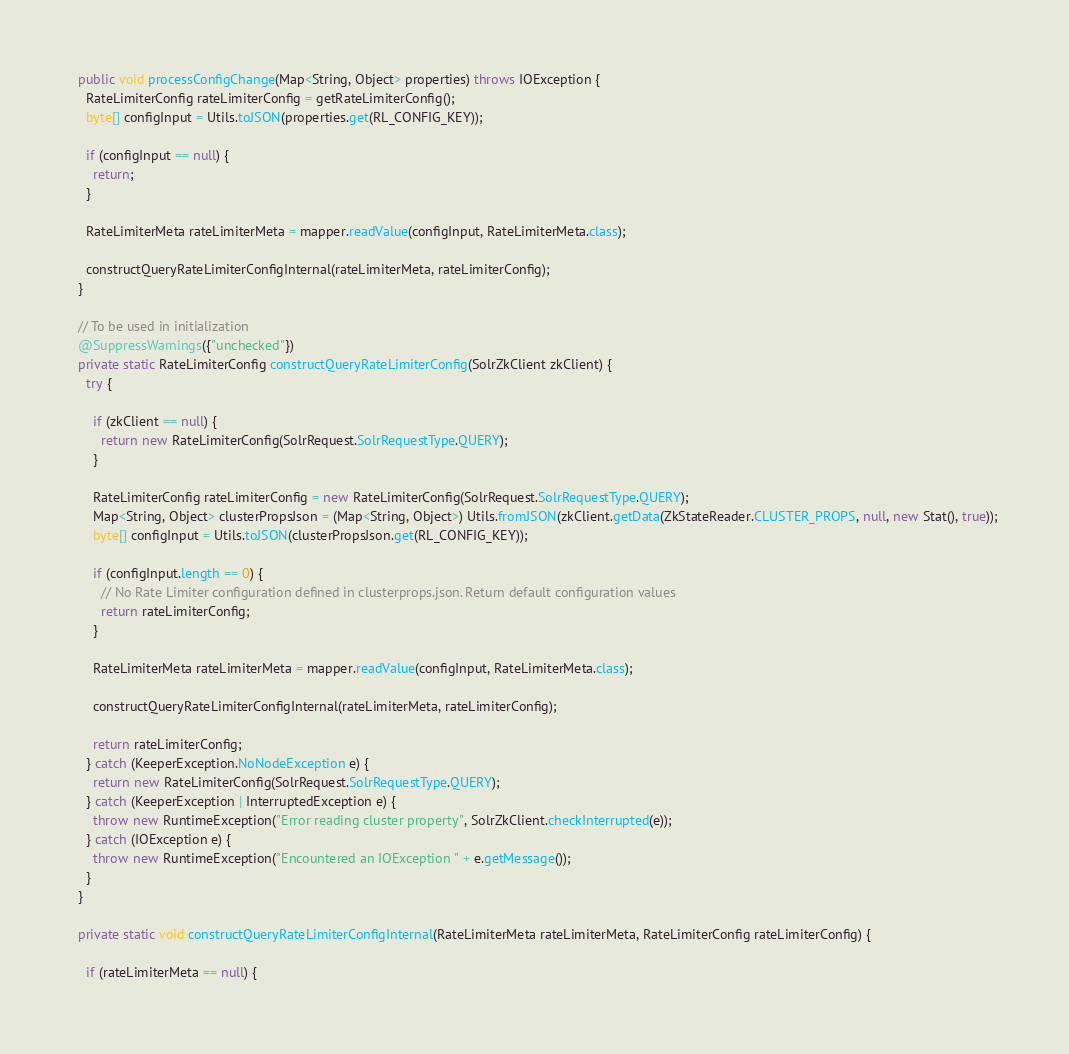Convert code to text. <code><loc_0><loc_0><loc_500><loc_500><_Java_>  public void processConfigChange(Map<String, Object> properties) throws IOException {
    RateLimiterConfig rateLimiterConfig = getRateLimiterConfig();
    byte[] configInput = Utils.toJSON(properties.get(RL_CONFIG_KEY));

    if (configInput == null) {
      return;
    }

    RateLimiterMeta rateLimiterMeta = mapper.readValue(configInput, RateLimiterMeta.class);

    constructQueryRateLimiterConfigInternal(rateLimiterMeta, rateLimiterConfig);
  }

  // To be used in initialization
  @SuppressWarnings({"unchecked"})
  private static RateLimiterConfig constructQueryRateLimiterConfig(SolrZkClient zkClient) {
    try {

      if (zkClient == null) {
        return new RateLimiterConfig(SolrRequest.SolrRequestType.QUERY);
      }

      RateLimiterConfig rateLimiterConfig = new RateLimiterConfig(SolrRequest.SolrRequestType.QUERY);
      Map<String, Object> clusterPropsJson = (Map<String, Object>) Utils.fromJSON(zkClient.getData(ZkStateReader.CLUSTER_PROPS, null, new Stat(), true));
      byte[] configInput = Utils.toJSON(clusterPropsJson.get(RL_CONFIG_KEY));

      if (configInput.length == 0) {
        // No Rate Limiter configuration defined in clusterprops.json. Return default configuration values
        return rateLimiterConfig;
      }

      RateLimiterMeta rateLimiterMeta = mapper.readValue(configInput, RateLimiterMeta.class);

      constructQueryRateLimiterConfigInternal(rateLimiterMeta, rateLimiterConfig);

      return rateLimiterConfig;
    } catch (KeeperException.NoNodeException e) {
      return new RateLimiterConfig(SolrRequest.SolrRequestType.QUERY);
    } catch (KeeperException | InterruptedException e) {
      throw new RuntimeException("Error reading cluster property", SolrZkClient.checkInterrupted(e));
    } catch (IOException e) {
      throw new RuntimeException("Encountered an IOException " + e.getMessage());
    }
  }

  private static void constructQueryRateLimiterConfigInternal(RateLimiterMeta rateLimiterMeta, RateLimiterConfig rateLimiterConfig) {

    if (rateLimiterMeta == null) {</code> 